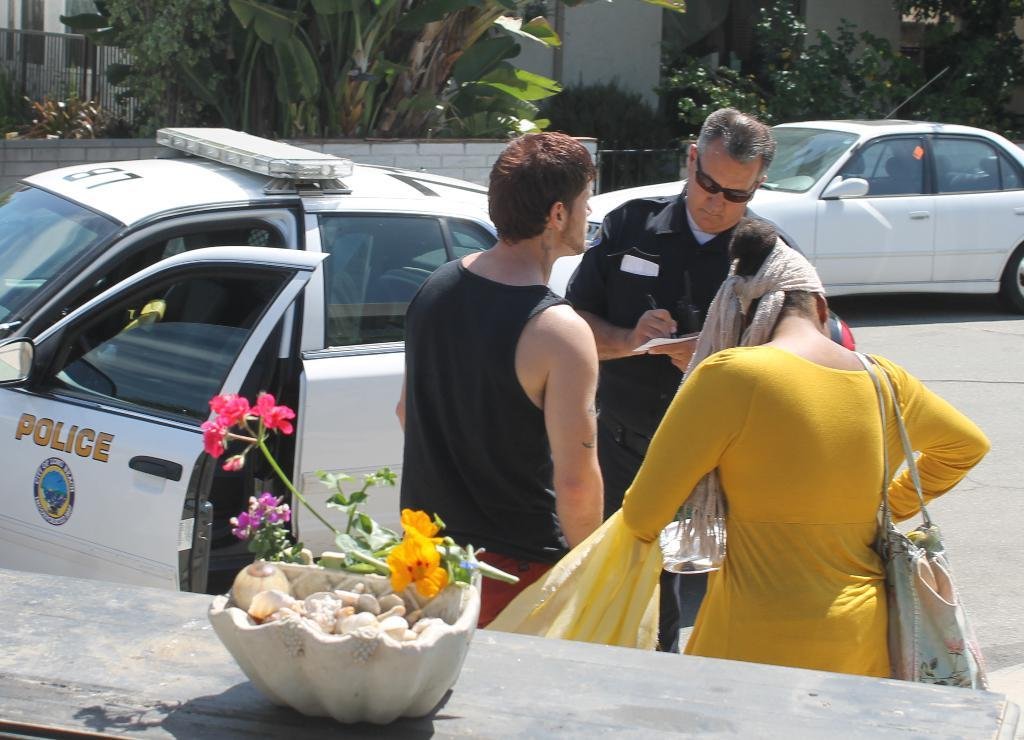<image>
Give a short and clear explanation of the subsequent image. A man and woman are standing on the side of the street, in front of a police officer that is by his police car. 